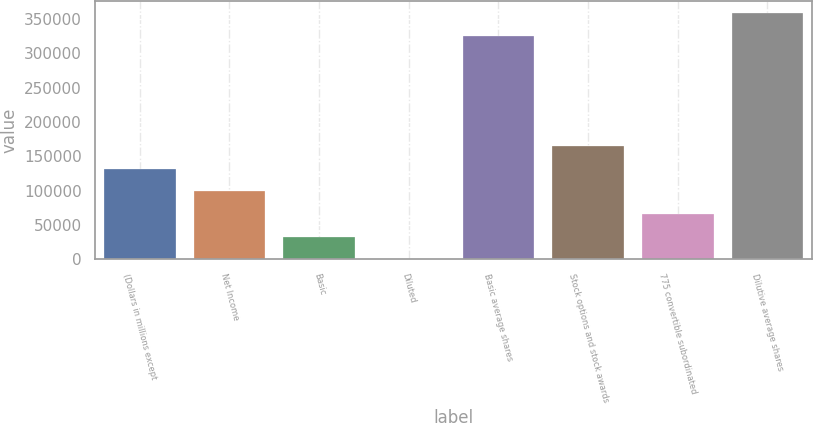<chart> <loc_0><loc_0><loc_500><loc_500><bar_chart><fcel>(Dollars in millions except<fcel>Net Income<fcel>Basic<fcel>Diluted<fcel>Basic average shares<fcel>Stock options and stock awards<fcel>775 convertible subordinated<fcel>Dilutive average shares<nl><fcel>132198<fcel>99148.9<fcel>33050.9<fcel>1.9<fcel>325030<fcel>165247<fcel>66099.9<fcel>358079<nl></chart> 